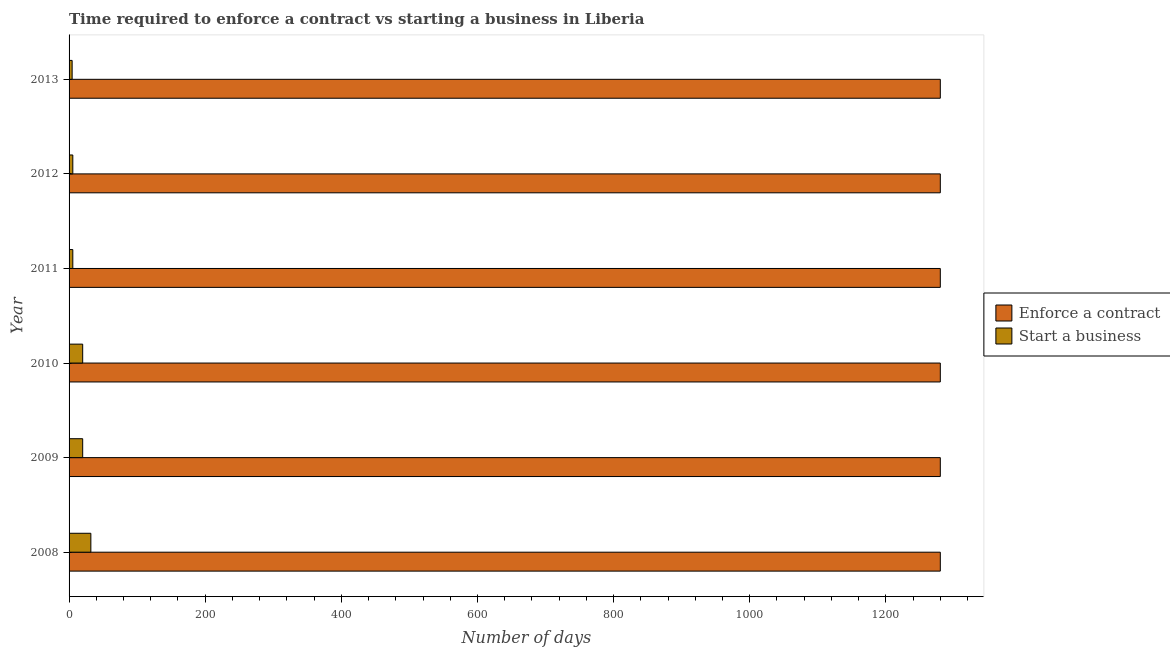How many groups of bars are there?
Provide a short and direct response. 6. How many bars are there on the 5th tick from the top?
Your response must be concise. 2. What is the label of the 5th group of bars from the top?
Make the answer very short. 2009. Across all years, what is the minimum number of days to enforece a contract?
Give a very brief answer. 1280. What is the total number of days to start a business in the graph?
Provide a short and direct response. 87.5. What is the difference between the number of days to start a business in 2010 and the number of days to enforece a contract in 2013?
Provide a short and direct response. -1260. What is the average number of days to enforece a contract per year?
Provide a succinct answer. 1280. In the year 2011, what is the difference between the number of days to start a business and number of days to enforece a contract?
Give a very brief answer. -1274.5. In how many years, is the number of days to start a business greater than 760 days?
Your answer should be very brief. 0. What is the ratio of the number of days to enforece a contract in 2011 to that in 2013?
Ensure brevity in your answer.  1. What is the difference between the highest and the second highest number of days to enforece a contract?
Offer a very short reply. 0. Is the sum of the number of days to enforece a contract in 2010 and 2011 greater than the maximum number of days to start a business across all years?
Provide a short and direct response. Yes. What does the 2nd bar from the top in 2010 represents?
Your answer should be compact. Enforce a contract. What does the 1st bar from the bottom in 2011 represents?
Keep it short and to the point. Enforce a contract. What is the difference between two consecutive major ticks on the X-axis?
Your response must be concise. 200. Are the values on the major ticks of X-axis written in scientific E-notation?
Ensure brevity in your answer.  No. Does the graph contain any zero values?
Make the answer very short. No. Does the graph contain grids?
Offer a very short reply. No. Where does the legend appear in the graph?
Give a very brief answer. Center right. How are the legend labels stacked?
Ensure brevity in your answer.  Vertical. What is the title of the graph?
Your answer should be compact. Time required to enforce a contract vs starting a business in Liberia. What is the label or title of the X-axis?
Your response must be concise. Number of days. What is the Number of days of Enforce a contract in 2008?
Ensure brevity in your answer.  1280. What is the Number of days of Enforce a contract in 2009?
Your response must be concise. 1280. What is the Number of days in Start a business in 2009?
Ensure brevity in your answer.  20. What is the Number of days of Enforce a contract in 2010?
Offer a terse response. 1280. What is the Number of days in Start a business in 2010?
Offer a terse response. 20. What is the Number of days of Enforce a contract in 2011?
Ensure brevity in your answer.  1280. What is the Number of days of Start a business in 2011?
Make the answer very short. 5.5. What is the Number of days in Enforce a contract in 2012?
Give a very brief answer. 1280. What is the Number of days in Enforce a contract in 2013?
Your answer should be very brief. 1280. Across all years, what is the maximum Number of days of Enforce a contract?
Offer a terse response. 1280. Across all years, what is the minimum Number of days of Enforce a contract?
Keep it short and to the point. 1280. Across all years, what is the minimum Number of days of Start a business?
Ensure brevity in your answer.  4.5. What is the total Number of days in Enforce a contract in the graph?
Keep it short and to the point. 7680. What is the total Number of days of Start a business in the graph?
Provide a short and direct response. 87.5. What is the difference between the Number of days in Start a business in 2008 and that in 2009?
Ensure brevity in your answer.  12. What is the difference between the Number of days of Start a business in 2008 and that in 2010?
Provide a succinct answer. 12. What is the difference between the Number of days of Enforce a contract in 2008 and that in 2011?
Make the answer very short. 0. What is the difference between the Number of days of Start a business in 2008 and that in 2011?
Provide a short and direct response. 26.5. What is the difference between the Number of days in Start a business in 2008 and that in 2012?
Provide a succinct answer. 26.5. What is the difference between the Number of days of Enforce a contract in 2008 and that in 2013?
Provide a succinct answer. 0. What is the difference between the Number of days of Enforce a contract in 2009 and that in 2010?
Keep it short and to the point. 0. What is the difference between the Number of days in Start a business in 2009 and that in 2010?
Offer a terse response. 0. What is the difference between the Number of days of Enforce a contract in 2009 and that in 2011?
Give a very brief answer. 0. What is the difference between the Number of days of Start a business in 2009 and that in 2011?
Your response must be concise. 14.5. What is the difference between the Number of days of Enforce a contract in 2009 and that in 2012?
Your answer should be compact. 0. What is the difference between the Number of days of Start a business in 2009 and that in 2012?
Ensure brevity in your answer.  14.5. What is the difference between the Number of days of Enforce a contract in 2009 and that in 2013?
Provide a succinct answer. 0. What is the difference between the Number of days in Start a business in 2009 and that in 2013?
Your response must be concise. 15.5. What is the difference between the Number of days in Start a business in 2010 and that in 2011?
Your response must be concise. 14.5. What is the difference between the Number of days of Enforce a contract in 2010 and that in 2012?
Your answer should be compact. 0. What is the difference between the Number of days in Enforce a contract in 2011 and that in 2013?
Your response must be concise. 0. What is the difference between the Number of days in Enforce a contract in 2008 and the Number of days in Start a business in 2009?
Offer a terse response. 1260. What is the difference between the Number of days in Enforce a contract in 2008 and the Number of days in Start a business in 2010?
Provide a succinct answer. 1260. What is the difference between the Number of days in Enforce a contract in 2008 and the Number of days in Start a business in 2011?
Your answer should be very brief. 1274.5. What is the difference between the Number of days of Enforce a contract in 2008 and the Number of days of Start a business in 2012?
Ensure brevity in your answer.  1274.5. What is the difference between the Number of days of Enforce a contract in 2008 and the Number of days of Start a business in 2013?
Provide a short and direct response. 1275.5. What is the difference between the Number of days of Enforce a contract in 2009 and the Number of days of Start a business in 2010?
Your response must be concise. 1260. What is the difference between the Number of days of Enforce a contract in 2009 and the Number of days of Start a business in 2011?
Your answer should be compact. 1274.5. What is the difference between the Number of days in Enforce a contract in 2009 and the Number of days in Start a business in 2012?
Keep it short and to the point. 1274.5. What is the difference between the Number of days in Enforce a contract in 2009 and the Number of days in Start a business in 2013?
Offer a very short reply. 1275.5. What is the difference between the Number of days of Enforce a contract in 2010 and the Number of days of Start a business in 2011?
Make the answer very short. 1274.5. What is the difference between the Number of days of Enforce a contract in 2010 and the Number of days of Start a business in 2012?
Provide a short and direct response. 1274.5. What is the difference between the Number of days in Enforce a contract in 2010 and the Number of days in Start a business in 2013?
Your answer should be very brief. 1275.5. What is the difference between the Number of days in Enforce a contract in 2011 and the Number of days in Start a business in 2012?
Your response must be concise. 1274.5. What is the difference between the Number of days in Enforce a contract in 2011 and the Number of days in Start a business in 2013?
Offer a very short reply. 1275.5. What is the difference between the Number of days of Enforce a contract in 2012 and the Number of days of Start a business in 2013?
Make the answer very short. 1275.5. What is the average Number of days of Enforce a contract per year?
Your response must be concise. 1280. What is the average Number of days of Start a business per year?
Keep it short and to the point. 14.58. In the year 2008, what is the difference between the Number of days in Enforce a contract and Number of days in Start a business?
Give a very brief answer. 1248. In the year 2009, what is the difference between the Number of days in Enforce a contract and Number of days in Start a business?
Ensure brevity in your answer.  1260. In the year 2010, what is the difference between the Number of days of Enforce a contract and Number of days of Start a business?
Offer a terse response. 1260. In the year 2011, what is the difference between the Number of days of Enforce a contract and Number of days of Start a business?
Keep it short and to the point. 1274.5. In the year 2012, what is the difference between the Number of days in Enforce a contract and Number of days in Start a business?
Your response must be concise. 1274.5. In the year 2013, what is the difference between the Number of days in Enforce a contract and Number of days in Start a business?
Offer a terse response. 1275.5. What is the ratio of the Number of days in Enforce a contract in 2008 to that in 2010?
Give a very brief answer. 1. What is the ratio of the Number of days of Start a business in 2008 to that in 2010?
Make the answer very short. 1.6. What is the ratio of the Number of days of Enforce a contract in 2008 to that in 2011?
Offer a terse response. 1. What is the ratio of the Number of days of Start a business in 2008 to that in 2011?
Ensure brevity in your answer.  5.82. What is the ratio of the Number of days of Enforce a contract in 2008 to that in 2012?
Keep it short and to the point. 1. What is the ratio of the Number of days of Start a business in 2008 to that in 2012?
Keep it short and to the point. 5.82. What is the ratio of the Number of days of Enforce a contract in 2008 to that in 2013?
Provide a succinct answer. 1. What is the ratio of the Number of days of Start a business in 2008 to that in 2013?
Keep it short and to the point. 7.11. What is the ratio of the Number of days of Enforce a contract in 2009 to that in 2010?
Offer a very short reply. 1. What is the ratio of the Number of days in Start a business in 2009 to that in 2011?
Provide a succinct answer. 3.64. What is the ratio of the Number of days in Enforce a contract in 2009 to that in 2012?
Offer a terse response. 1. What is the ratio of the Number of days in Start a business in 2009 to that in 2012?
Give a very brief answer. 3.64. What is the ratio of the Number of days of Start a business in 2009 to that in 2013?
Your response must be concise. 4.44. What is the ratio of the Number of days of Enforce a contract in 2010 to that in 2011?
Your answer should be compact. 1. What is the ratio of the Number of days of Start a business in 2010 to that in 2011?
Your answer should be compact. 3.64. What is the ratio of the Number of days in Enforce a contract in 2010 to that in 2012?
Offer a very short reply. 1. What is the ratio of the Number of days of Start a business in 2010 to that in 2012?
Offer a very short reply. 3.64. What is the ratio of the Number of days of Start a business in 2010 to that in 2013?
Your answer should be very brief. 4.44. What is the ratio of the Number of days in Start a business in 2011 to that in 2012?
Your response must be concise. 1. What is the ratio of the Number of days of Enforce a contract in 2011 to that in 2013?
Offer a terse response. 1. What is the ratio of the Number of days in Start a business in 2011 to that in 2013?
Offer a very short reply. 1.22. What is the ratio of the Number of days of Start a business in 2012 to that in 2013?
Ensure brevity in your answer.  1.22. What is the difference between the highest and the second highest Number of days of Start a business?
Your response must be concise. 12. 